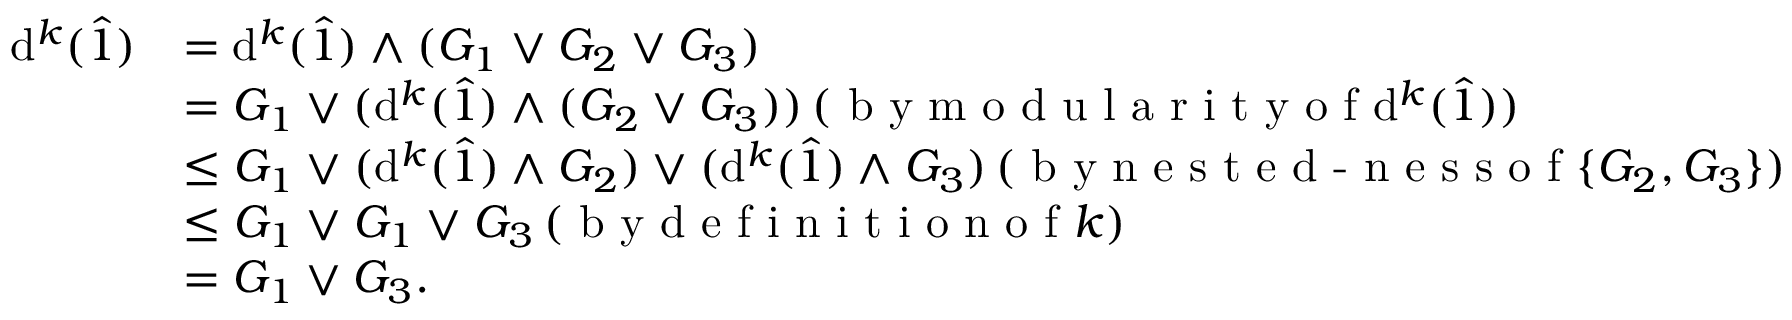Convert formula to latex. <formula><loc_0><loc_0><loc_500><loc_500>\begin{array} { r l } { d ^ { k } ( \hat { 1 } ) } & { = d ^ { k } ( \hat { 1 } ) \wedge ( G _ { 1 } \vee G _ { 2 } \vee G _ { 3 } ) } \\ & { = G _ { 1 } \vee ( d ^ { k } ( \hat { 1 } ) \wedge ( G _ { 2 } \vee G _ { 3 } ) ) \, ( b y m o d u l a r i t y o f d ^ { k } ( \hat { 1 } ) ) } \\ & { \leq G _ { 1 } \vee ( d ^ { k } ( \hat { 1 } ) \wedge G _ { 2 } ) \vee ( d ^ { k } ( \hat { 1 } ) \wedge G _ { 3 } ) \, ( b y n e s t e d - n e s s o f \{ G _ { 2 } , G _ { 3 } \} ) } \\ & { \leq G _ { 1 } \vee G _ { 1 } \vee G _ { 3 } \, ( b y d e f i n i t i o n o f k ) } \\ & { = G _ { 1 } \vee G _ { 3 } . } \end{array}</formula> 